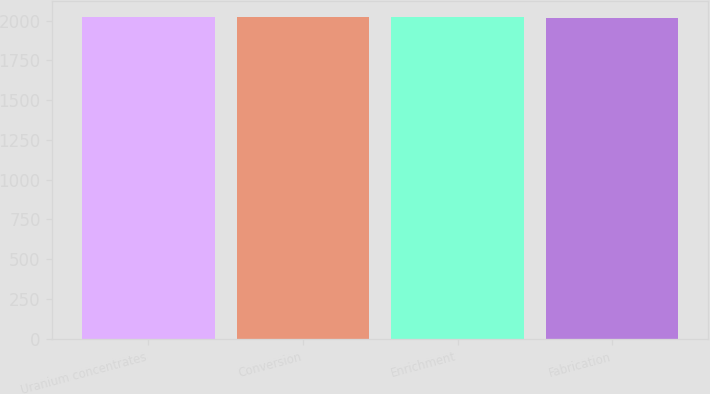<chart> <loc_0><loc_0><loc_500><loc_500><bar_chart><fcel>Uranium concentrates<fcel>Conversion<fcel>Enrichment<fcel>Fabrication<nl><fcel>2020<fcel>2020.5<fcel>2021<fcel>2015<nl></chart> 